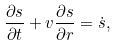<formula> <loc_0><loc_0><loc_500><loc_500>\frac { \partial s } { \partial t } + v \frac { \partial s } { \partial r } = \dot { s } ,</formula> 